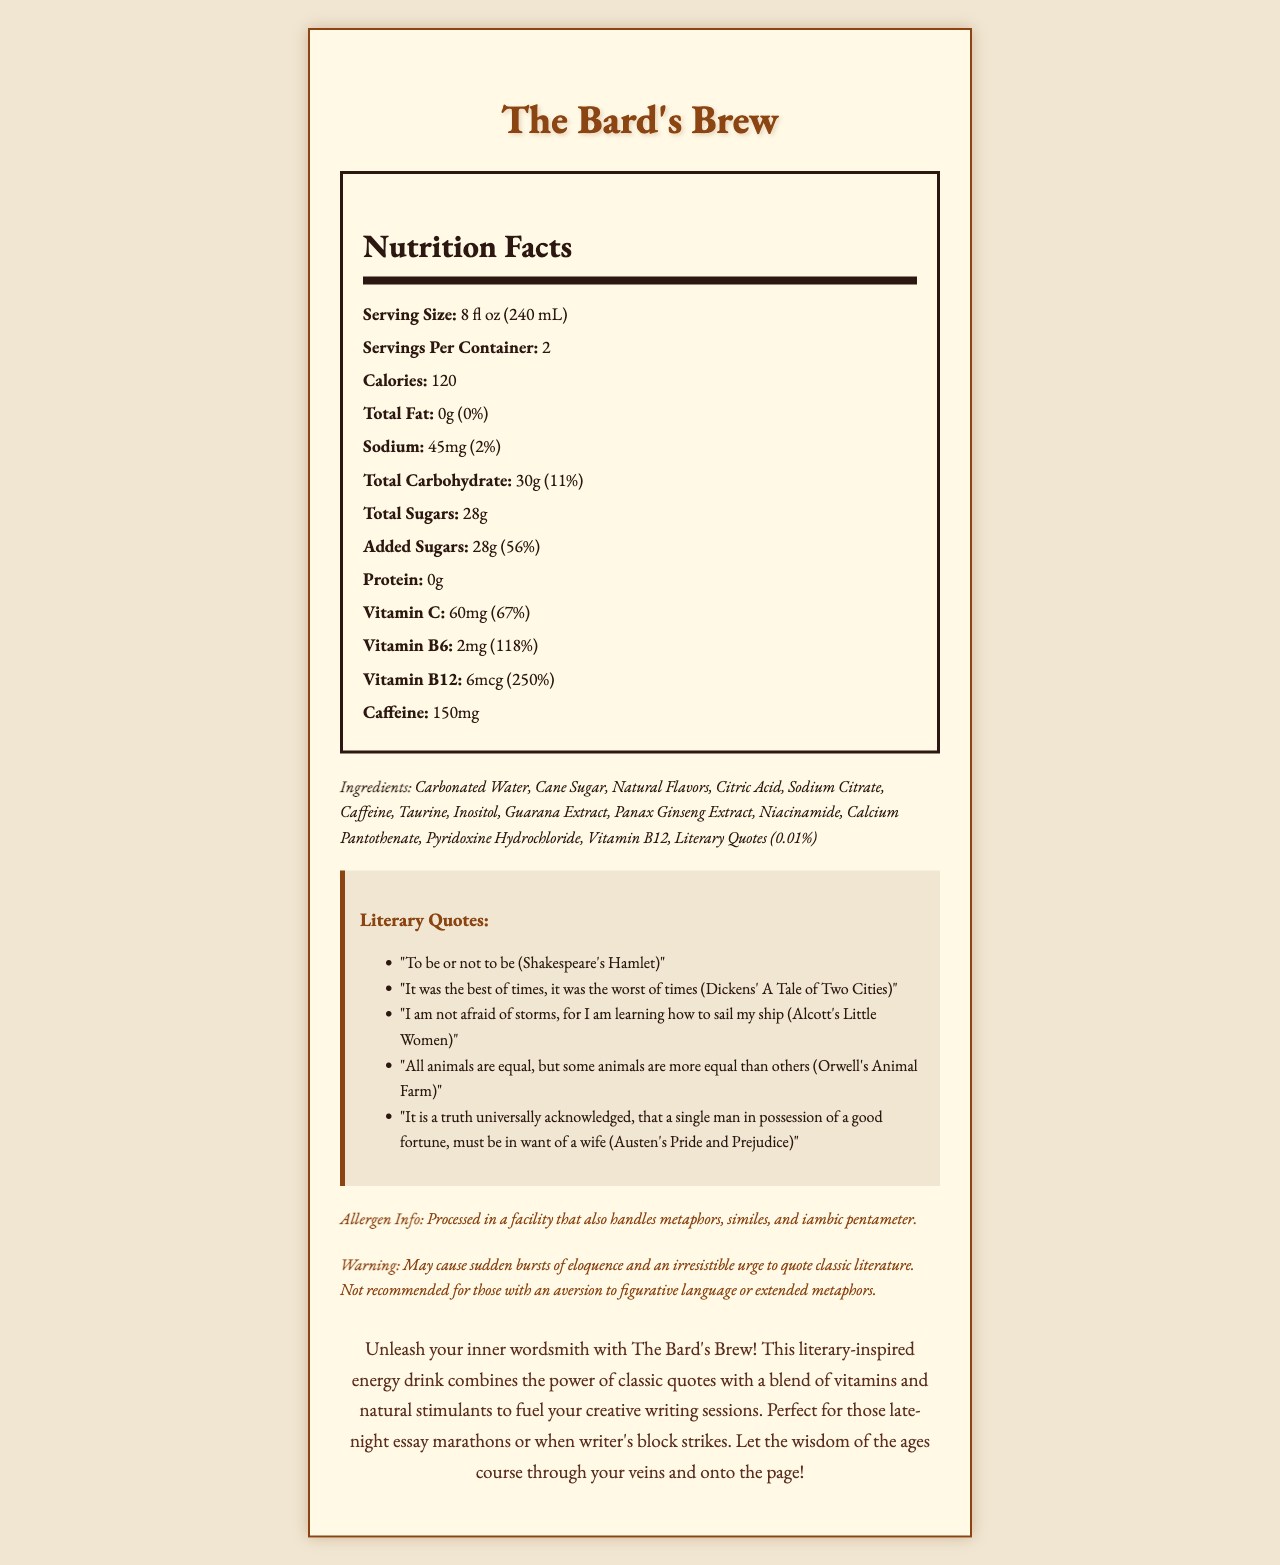what is the serving size? The serving size is stated at the beginning of the nutrition facts section of the document as 8 fl oz (240 mL).
Answer: 8 fl oz (240 mL) how many calories are there per serving? The document lists the number of calories per serving clearly as 120.
Answer: 120 how much vitamin B12 is in one serving? The amount of vitamin B12 per serving is specified in the nutrition facts section as 6mcg.
Answer: 6mcg what is the daily value percentage of added sugars? In the nutrition facts section, added sugars are noted to have a daily value of 56%.
Answer: 56% how much caffeine does The Bard's Brew contain? The document mentions that the caffeine content of The Bard's Brew is 150mg.
Answer: 150mg which literary work is the quote "To be or not to be" from? A. Pride and Prejudice B. Animal Farm C. Hamlet The quote "To be or not to be" is from Shakespeare's Hamlet, which is listed in the literary quotes section.
Answer: C what is the percentage of daily value for Vitamin C? A. 67% B. 50% C. 100% D. 30% The document states that the daily value percentage for Vitamin C is 67%.
Answer: A does the product contain any protein? The nutrition facts section indicates that there is 0g of protein per serving.
Answer: No summarize the main idea of the document. The document describes The Bard's Brew as an energy drink filled with literary quotes and beneficial vitamins, designed to inspire and energize writers.
Answer: The Bard's Brew is a novel-inspired energy drink that combines literary quotes with a blend of vitamins and natural stimulants, aiming to enhance creative writing sessions. what is the total amount of sugar in the entire container? Since there are 28g of total sugars per serving and 2 servings per container, the total amount is 28g x 2 = 56g.
Answer: 56g how many servings per container are there? The document specifies that there are 2 servings per container in the nutrition facts section.
Answer: 2 what warning is provided for this product? The warning listed in the document gives this specific information.
Answer: May cause sudden bursts of eloquence and an irresistible urge to quote classic literature. Not recommended for those with an aversion to figurative language or extended metaphors. how much sodium is in one serving? The nutrition facts section shows that there are 45mg of sodium per serving.
Answer: 45mg which ingredient is listed last in The Bard's Brew? The ingredients list at the bottom of the document ends with "Literary Quotes (0.01%)".
Answer: Literary Quotes (0.01%) what happens if you dislike figurative language? The warning section mentions that the product is not recommended for those with an aversion to figurative language.
Answer: You should avoid this product. is the sodium content high in this energy drink compared to the daily value? The sodium content is 45mg per serving, which is only 2% of the daily value, indicating it is relatively low.
Answer: No what kind of facility processes this product? The allergen info humorously mentions that the product is processed in a facility handling these literary devices.
Answer: A facility that also handles metaphors, similes, and iambic pentameter. how many grams of total carbohydrates are there per serving? The document indicates that there are 30g of total carbohydrates per serving.
Answer: 30g can you determine the exact flavor of The Bard's Brew from the document? The document lists "Natural Flavors" but does not specify the exact flavor.
Answer: Cannot be determined what is the product name? The product name is stated at the top and throughout the document as The Bard's Brew.
Answer: The Bard's Brew 